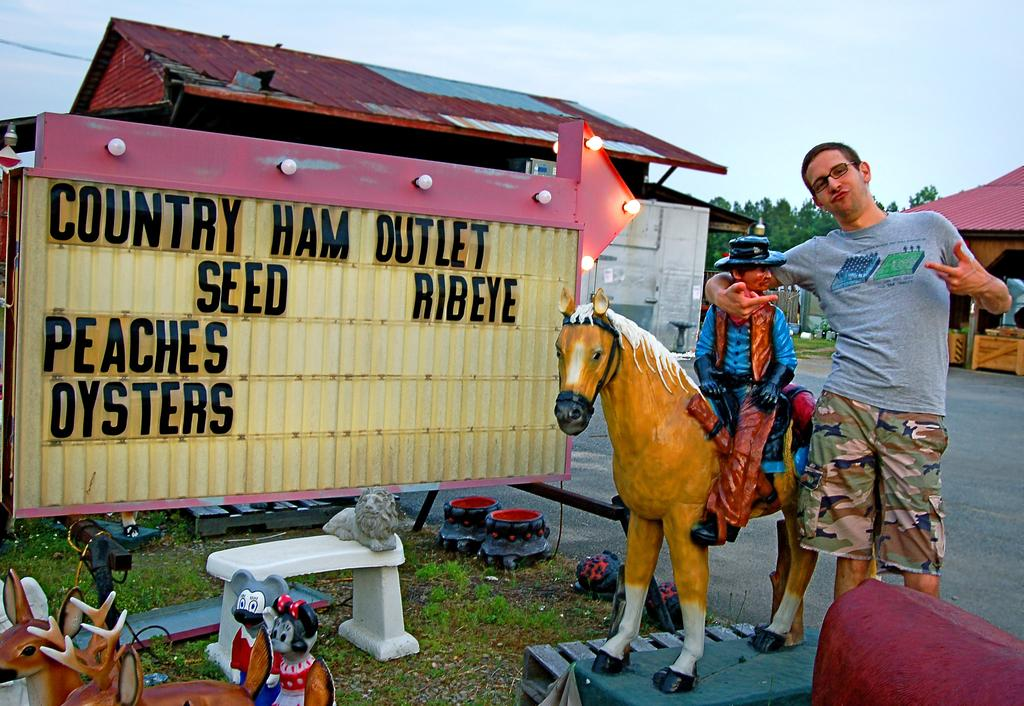Who is present in the image? There is a man in the image. What is the man doing in the image? The man is standing by holding a cowboy statue. What type of cough does the cowboy statue have in the image? There is no indication of a cough in the image, as the cowboy statue is an inanimate object. 